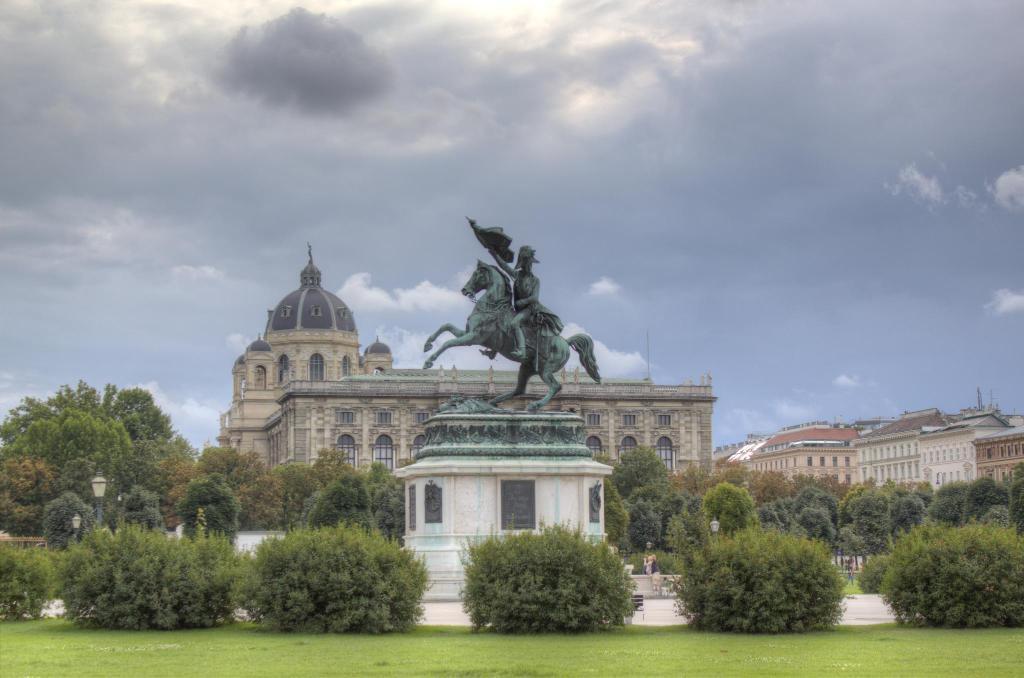Could you give a brief overview of what you see in this image? In this image I can see a building ,in front of the building I can see a sculpture and I can see trees 